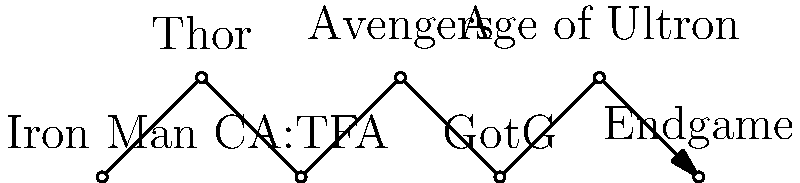In the MCU timeline network diagram, which movie directly precedes "Avengers" and is crucial for understanding Captain America's origin story? To answer this question, let's analyze the network diagram step-by-step:

1. The diagram shows a simplified timeline of key MCU movies.
2. The movies are represented as nodes, connected by arrows indicating the chronological order.
3. We need to identify the movie that comes directly before "Avengers" in the timeline.
4. Looking at the diagram, we see that "Avengers" is the fourth node from the left.
5. The node directly preceding "Avengers" is labeled "CA:TFA".
6. "CA:TFA" stands for "Captain America: The First Avenger".
7. This movie indeed tells the origin story of Captain America, set during World War II.
8. It's crucial for understanding Captain America's background before he joins the Avengers team.

Therefore, "Captain America: The First Avenger" is the correct answer, as it directly precedes "Avengers" in the timeline and provides essential backstory for Captain America.
Answer: Captain America: The First Avenger 